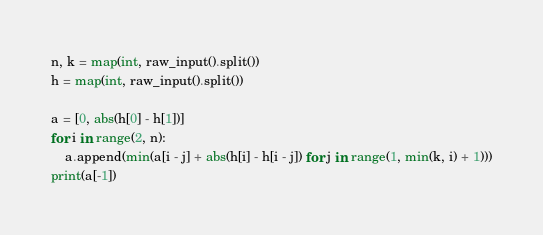<code> <loc_0><loc_0><loc_500><loc_500><_Python_>n, k = map(int, raw_input().split())
h = map(int, raw_input().split())

a = [0, abs(h[0] - h[1])]
for i in range(2, n):
    a.append(min(a[i - j] + abs(h[i] - h[i - j]) for j in range(1, min(k, i) + 1)))
print(a[-1])</code> 